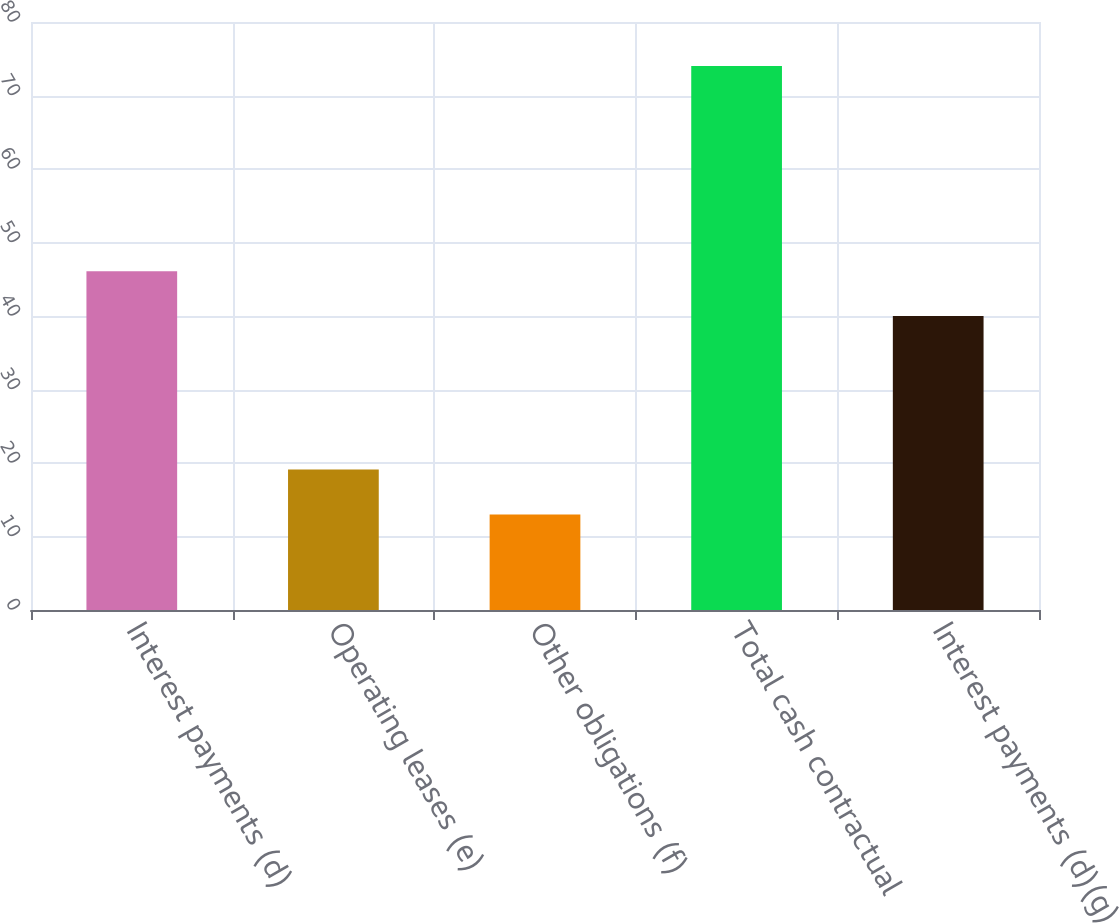<chart> <loc_0><loc_0><loc_500><loc_500><bar_chart><fcel>Interest payments (d)<fcel>Operating leases (e)<fcel>Other obligations (f)<fcel>Total cash contractual<fcel>Interest payments (d)(g)<nl><fcel>46.1<fcel>19.1<fcel>13<fcel>74<fcel>40<nl></chart> 